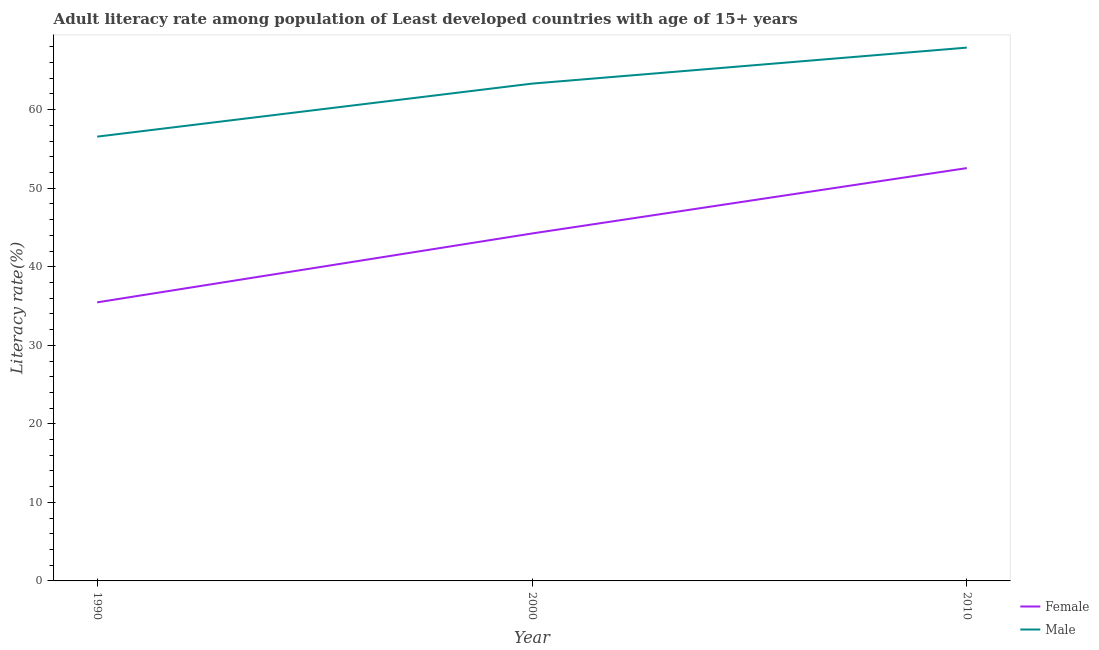Does the line corresponding to male adult literacy rate intersect with the line corresponding to female adult literacy rate?
Your answer should be compact. No. What is the male adult literacy rate in 2010?
Make the answer very short. 67.9. Across all years, what is the maximum female adult literacy rate?
Provide a succinct answer. 52.56. Across all years, what is the minimum male adult literacy rate?
Offer a very short reply. 56.57. What is the total male adult literacy rate in the graph?
Ensure brevity in your answer.  187.79. What is the difference between the male adult literacy rate in 1990 and that in 2010?
Your answer should be very brief. -11.34. What is the difference between the female adult literacy rate in 1990 and the male adult literacy rate in 2000?
Offer a very short reply. -27.85. What is the average female adult literacy rate per year?
Offer a very short reply. 44.09. In the year 2000, what is the difference between the female adult literacy rate and male adult literacy rate?
Give a very brief answer. -19.08. What is the ratio of the female adult literacy rate in 1990 to that in 2010?
Your answer should be very brief. 0.67. Is the difference between the female adult literacy rate in 1990 and 2010 greater than the difference between the male adult literacy rate in 1990 and 2010?
Your response must be concise. No. What is the difference between the highest and the second highest male adult literacy rate?
Your answer should be compact. 4.59. What is the difference between the highest and the lowest male adult literacy rate?
Your response must be concise. 11.34. Is the sum of the female adult literacy rate in 2000 and 2010 greater than the maximum male adult literacy rate across all years?
Your answer should be very brief. Yes. Does the female adult literacy rate monotonically increase over the years?
Provide a succinct answer. Yes. Is the male adult literacy rate strictly greater than the female adult literacy rate over the years?
Offer a very short reply. Yes. How many lines are there?
Your answer should be very brief. 2. Are the values on the major ticks of Y-axis written in scientific E-notation?
Provide a succinct answer. No. How many legend labels are there?
Your response must be concise. 2. How are the legend labels stacked?
Your answer should be very brief. Vertical. What is the title of the graph?
Your response must be concise. Adult literacy rate among population of Least developed countries with age of 15+ years. What is the label or title of the Y-axis?
Offer a very short reply. Literacy rate(%). What is the Literacy rate(%) of Female in 1990?
Offer a very short reply. 35.47. What is the Literacy rate(%) of Male in 1990?
Offer a terse response. 56.57. What is the Literacy rate(%) of Female in 2000?
Your answer should be very brief. 44.24. What is the Literacy rate(%) in Male in 2000?
Keep it short and to the point. 63.32. What is the Literacy rate(%) of Female in 2010?
Keep it short and to the point. 52.56. What is the Literacy rate(%) in Male in 2010?
Make the answer very short. 67.9. Across all years, what is the maximum Literacy rate(%) in Female?
Provide a short and direct response. 52.56. Across all years, what is the maximum Literacy rate(%) in Male?
Keep it short and to the point. 67.9. Across all years, what is the minimum Literacy rate(%) of Female?
Your answer should be very brief. 35.47. Across all years, what is the minimum Literacy rate(%) in Male?
Your answer should be very brief. 56.57. What is the total Literacy rate(%) of Female in the graph?
Give a very brief answer. 132.27. What is the total Literacy rate(%) of Male in the graph?
Offer a very short reply. 187.79. What is the difference between the Literacy rate(%) of Female in 1990 and that in 2000?
Offer a very short reply. -8.77. What is the difference between the Literacy rate(%) in Male in 1990 and that in 2000?
Ensure brevity in your answer.  -6.75. What is the difference between the Literacy rate(%) of Female in 1990 and that in 2010?
Ensure brevity in your answer.  -17.09. What is the difference between the Literacy rate(%) of Male in 1990 and that in 2010?
Your answer should be very brief. -11.34. What is the difference between the Literacy rate(%) of Female in 2000 and that in 2010?
Provide a succinct answer. -8.32. What is the difference between the Literacy rate(%) of Male in 2000 and that in 2010?
Provide a succinct answer. -4.59. What is the difference between the Literacy rate(%) in Female in 1990 and the Literacy rate(%) in Male in 2000?
Make the answer very short. -27.85. What is the difference between the Literacy rate(%) in Female in 1990 and the Literacy rate(%) in Male in 2010?
Make the answer very short. -32.43. What is the difference between the Literacy rate(%) in Female in 2000 and the Literacy rate(%) in Male in 2010?
Provide a succinct answer. -23.67. What is the average Literacy rate(%) of Female per year?
Provide a succinct answer. 44.09. What is the average Literacy rate(%) in Male per year?
Provide a succinct answer. 62.6. In the year 1990, what is the difference between the Literacy rate(%) in Female and Literacy rate(%) in Male?
Provide a succinct answer. -21.1. In the year 2000, what is the difference between the Literacy rate(%) of Female and Literacy rate(%) of Male?
Offer a very short reply. -19.08. In the year 2010, what is the difference between the Literacy rate(%) in Female and Literacy rate(%) in Male?
Your response must be concise. -15.34. What is the ratio of the Literacy rate(%) in Female in 1990 to that in 2000?
Make the answer very short. 0.8. What is the ratio of the Literacy rate(%) in Male in 1990 to that in 2000?
Keep it short and to the point. 0.89. What is the ratio of the Literacy rate(%) of Female in 1990 to that in 2010?
Give a very brief answer. 0.67. What is the ratio of the Literacy rate(%) of Male in 1990 to that in 2010?
Your answer should be compact. 0.83. What is the ratio of the Literacy rate(%) of Female in 2000 to that in 2010?
Keep it short and to the point. 0.84. What is the ratio of the Literacy rate(%) of Male in 2000 to that in 2010?
Ensure brevity in your answer.  0.93. What is the difference between the highest and the second highest Literacy rate(%) in Female?
Give a very brief answer. 8.32. What is the difference between the highest and the second highest Literacy rate(%) in Male?
Provide a short and direct response. 4.59. What is the difference between the highest and the lowest Literacy rate(%) of Female?
Offer a very short reply. 17.09. What is the difference between the highest and the lowest Literacy rate(%) of Male?
Your answer should be compact. 11.34. 